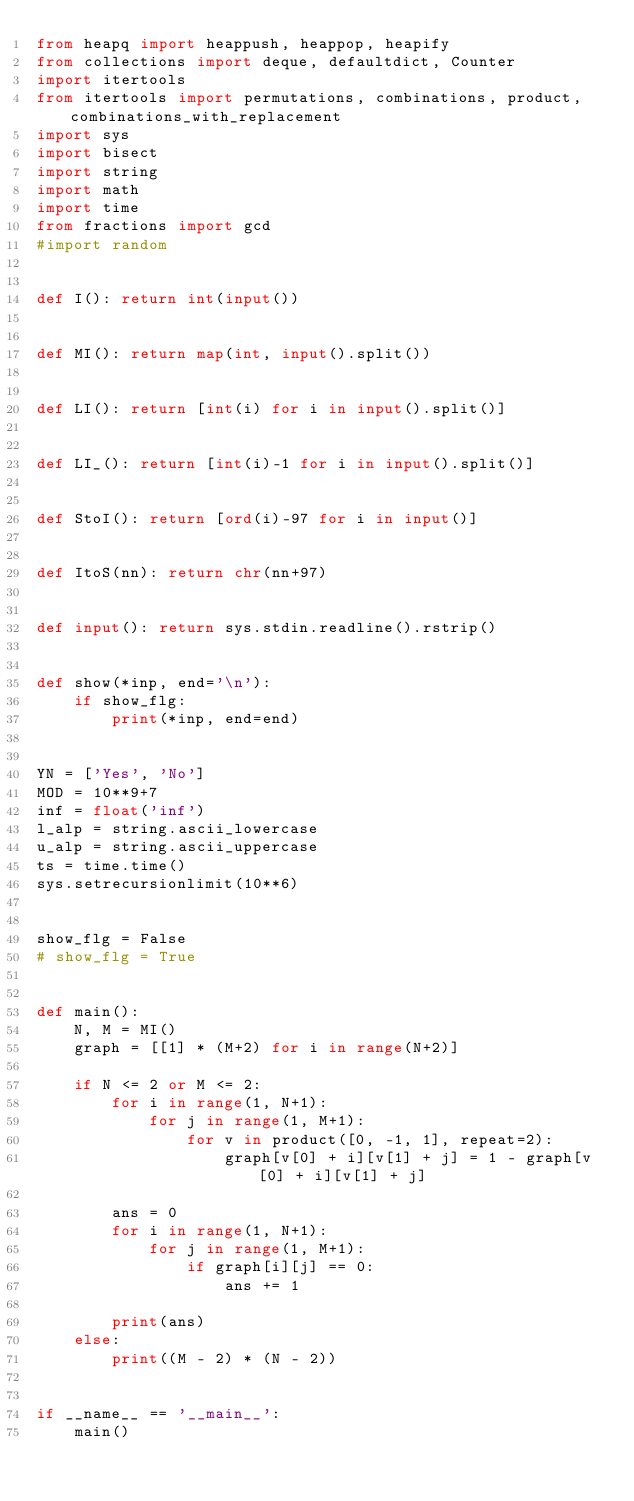<code> <loc_0><loc_0><loc_500><loc_500><_Python_>from heapq import heappush, heappop, heapify
from collections import deque, defaultdict, Counter
import itertools
from itertools import permutations, combinations, product, combinations_with_replacement
import sys
import bisect
import string
import math
import time
from fractions import gcd
#import random


def I(): return int(input())


def MI(): return map(int, input().split())


def LI(): return [int(i) for i in input().split()]


def LI_(): return [int(i)-1 for i in input().split()]


def StoI(): return [ord(i)-97 for i in input()]


def ItoS(nn): return chr(nn+97)


def input(): return sys.stdin.readline().rstrip()


def show(*inp, end='\n'):
    if show_flg:
        print(*inp, end=end)


YN = ['Yes', 'No']
MOD = 10**9+7
inf = float('inf')
l_alp = string.ascii_lowercase
u_alp = string.ascii_uppercase
ts = time.time()
sys.setrecursionlimit(10**6)


show_flg = False
# show_flg = True


def main():
    N, M = MI()
    graph = [[1] * (M+2) for i in range(N+2)]

    if N <= 2 or M <= 2:
        for i in range(1, N+1):
            for j in range(1, M+1):
                for v in product([0, -1, 1], repeat=2):
                    graph[v[0] + i][v[1] + j] = 1 - graph[v[0] + i][v[1] + j]

        ans = 0
        for i in range(1, N+1):
            for j in range(1, M+1):
                if graph[i][j] == 0:
                    ans += 1

        print(ans)
    else:
        print((M - 2) * (N - 2))


if __name__ == '__main__':
    main()
</code> 